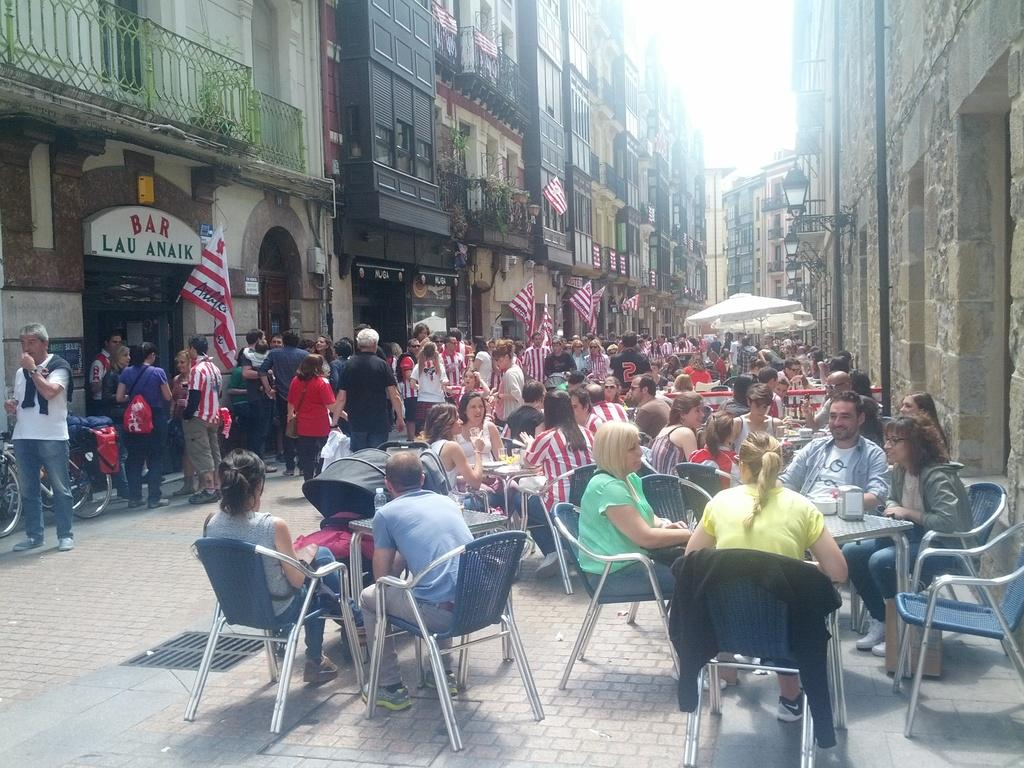How many people are present in the image? There are lots of people in the image. What are some of the people doing in the image? Some people are walking on the road, while others are sitting. What can be seen in the image besides people? There are flags, buildings, and plants in the image. Where is the expert patching the hole in the image? There is no expert or hole present in the image. 